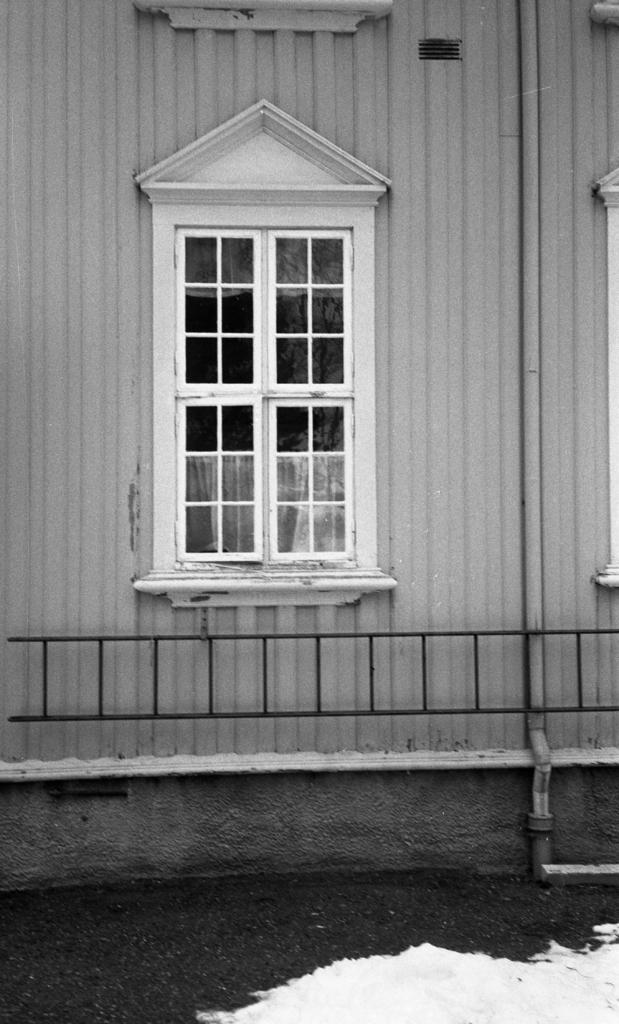Describe this image in one or two sentences. This is a black and white picture, in this image we can see a building with a window and also we can see a pole and the grille. 